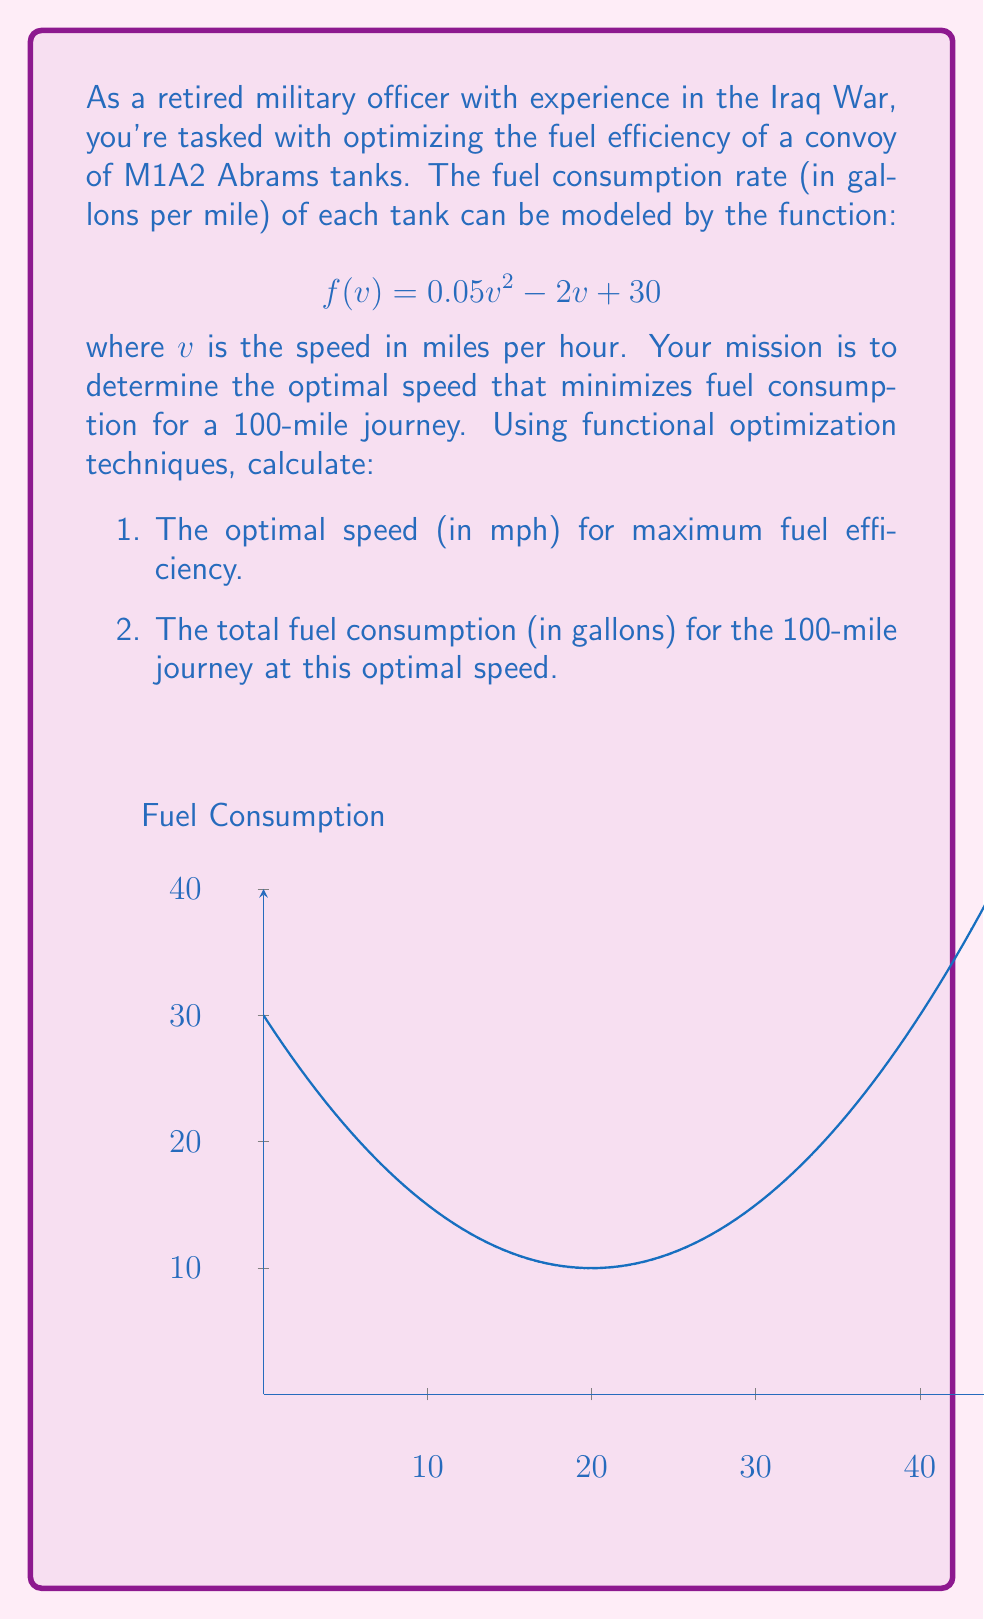Help me with this question. Let's approach this problem step-by-step using functional optimization techniques:

1) To find the optimal speed, we need to minimize the function $f(v)$. In calculus, we know that the minimum of a function occurs where its derivative equals zero.

2) Let's find the derivative of $f(v)$:
   $$f'(v) = 0.1v - 2$$

3) Set the derivative to zero and solve for v:
   $$0.1v - 2 = 0$$
   $$0.1v = 2$$
   $$v = 20$$

4) To confirm this is a minimum (not a maximum), we can check the second derivative:
   $$f''(v) = 0.1 > 0$$
   Since $f''(v)$ is positive, we confirm that $v = 20$ gives a minimum.

5) So, the optimal speed for maximum fuel efficiency is 20 mph.

6) Now, let's calculate the fuel consumption for the 100-mile journey at this speed:
   $$f(20) = 0.05(20)^2 - 2(20) + 30$$
   $$= 0.05(400) - 40 + 30$$
   $$= 20 - 40 + 30 = 10$$

   This means the tank consumes 10 gallons per mile at the optimal speed.

7) For a 100-mile journey, the total fuel consumption would be:
   $$100 \text{ miles} \times 10 \text{ gallons/mile} = 1000 \text{ gallons}$$

Therefore, the optimal speed is 20 mph, and the total fuel consumption for the 100-mile journey at this speed is 1000 gallons.
Answer: 20 mph; 1000 gallons 